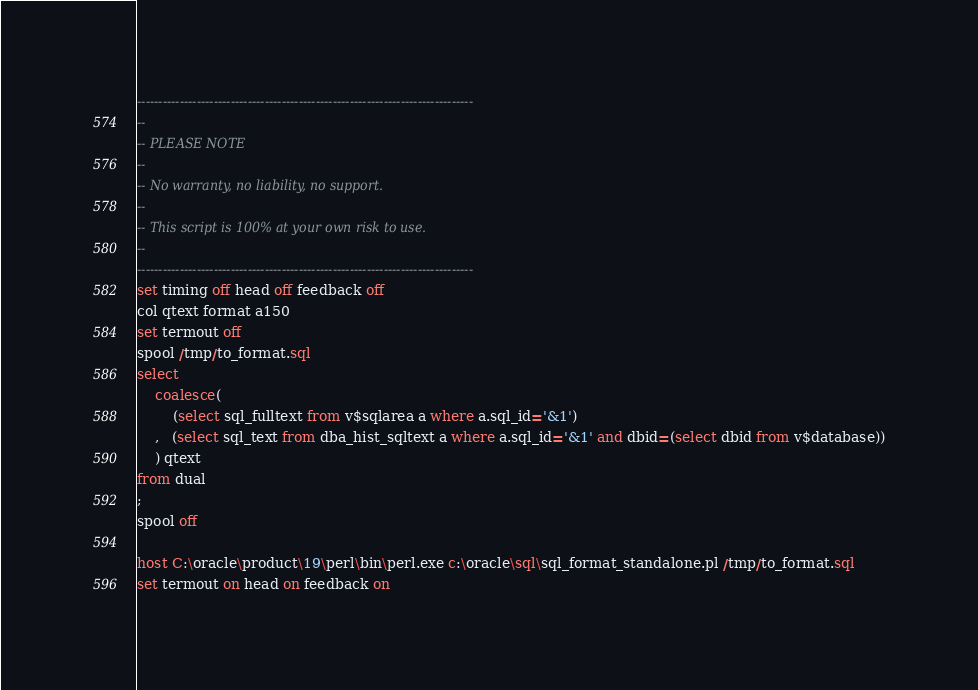Convert code to text. <code><loc_0><loc_0><loc_500><loc_500><_SQL_>-------------------------------------------------------------------------------
--
-- PLEASE NOTE
-- 
-- No warranty, no liability, no support.
--
-- This script is 100% at your own risk to use.
--
-------------------------------------------------------------------------------
set timing off head off feedback off
col qtext format a150
set termout off
spool /tmp/to_format.sql
select
    coalesce(
        (select sql_fulltext from v$sqlarea a where a.sql_id='&1')
    ,   (select sql_text from dba_hist_sqltext a where a.sql_id='&1' and dbid=(select dbid from v$database))
    ) qtext
from dual
;
spool off
 
host C:\oracle\product\19\perl\bin\perl.exe c:\oracle\sql\sql_format_standalone.pl /tmp/to_format.sql
set termout on head on feedback on
</code> 